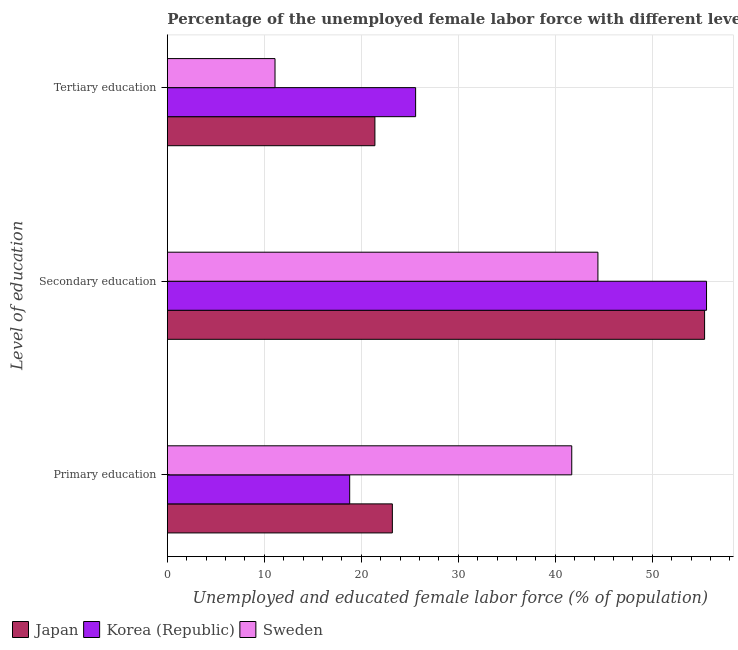How many groups of bars are there?
Keep it short and to the point. 3. How many bars are there on the 1st tick from the top?
Your answer should be very brief. 3. What is the label of the 2nd group of bars from the top?
Your answer should be compact. Secondary education. What is the percentage of female labor force who received tertiary education in Sweden?
Your answer should be compact. 11.1. Across all countries, what is the maximum percentage of female labor force who received tertiary education?
Keep it short and to the point. 25.6. Across all countries, what is the minimum percentage of female labor force who received primary education?
Keep it short and to the point. 18.8. In which country was the percentage of female labor force who received tertiary education minimum?
Keep it short and to the point. Sweden. What is the total percentage of female labor force who received secondary education in the graph?
Provide a short and direct response. 155.4. What is the difference between the percentage of female labor force who received secondary education in Korea (Republic) and that in Japan?
Offer a terse response. 0.2. What is the difference between the percentage of female labor force who received primary education in Sweden and the percentage of female labor force who received tertiary education in Japan?
Give a very brief answer. 20.3. What is the average percentage of female labor force who received secondary education per country?
Provide a short and direct response. 51.8. What is the difference between the percentage of female labor force who received tertiary education and percentage of female labor force who received primary education in Sweden?
Make the answer very short. -30.6. In how many countries, is the percentage of female labor force who received tertiary education greater than 46 %?
Provide a short and direct response. 0. What is the ratio of the percentage of female labor force who received tertiary education in Japan to that in Sweden?
Provide a short and direct response. 1.93. Is the difference between the percentage of female labor force who received primary education in Sweden and Korea (Republic) greater than the difference between the percentage of female labor force who received tertiary education in Sweden and Korea (Republic)?
Your answer should be very brief. Yes. What is the difference between the highest and the second highest percentage of female labor force who received secondary education?
Your answer should be compact. 0.2. What is the difference between the highest and the lowest percentage of female labor force who received primary education?
Give a very brief answer. 22.9. In how many countries, is the percentage of female labor force who received primary education greater than the average percentage of female labor force who received primary education taken over all countries?
Your answer should be very brief. 1. What does the 2nd bar from the bottom in Secondary education represents?
Keep it short and to the point. Korea (Republic). Is it the case that in every country, the sum of the percentage of female labor force who received primary education and percentage of female labor force who received secondary education is greater than the percentage of female labor force who received tertiary education?
Offer a very short reply. Yes. How many countries are there in the graph?
Give a very brief answer. 3. What is the difference between two consecutive major ticks on the X-axis?
Provide a short and direct response. 10. Does the graph contain grids?
Offer a very short reply. Yes. How many legend labels are there?
Ensure brevity in your answer.  3. How are the legend labels stacked?
Offer a very short reply. Horizontal. What is the title of the graph?
Keep it short and to the point. Percentage of the unemployed female labor force with different levels of education in countries. Does "Grenada" appear as one of the legend labels in the graph?
Provide a short and direct response. No. What is the label or title of the X-axis?
Your answer should be very brief. Unemployed and educated female labor force (% of population). What is the label or title of the Y-axis?
Give a very brief answer. Level of education. What is the Unemployed and educated female labor force (% of population) of Japan in Primary education?
Provide a short and direct response. 23.2. What is the Unemployed and educated female labor force (% of population) of Korea (Republic) in Primary education?
Your answer should be compact. 18.8. What is the Unemployed and educated female labor force (% of population) of Sweden in Primary education?
Your answer should be compact. 41.7. What is the Unemployed and educated female labor force (% of population) of Japan in Secondary education?
Ensure brevity in your answer.  55.4. What is the Unemployed and educated female labor force (% of population) in Korea (Republic) in Secondary education?
Offer a terse response. 55.6. What is the Unemployed and educated female labor force (% of population) in Sweden in Secondary education?
Your answer should be compact. 44.4. What is the Unemployed and educated female labor force (% of population) of Japan in Tertiary education?
Your answer should be very brief. 21.4. What is the Unemployed and educated female labor force (% of population) in Korea (Republic) in Tertiary education?
Give a very brief answer. 25.6. What is the Unemployed and educated female labor force (% of population) in Sweden in Tertiary education?
Ensure brevity in your answer.  11.1. Across all Level of education, what is the maximum Unemployed and educated female labor force (% of population) in Japan?
Keep it short and to the point. 55.4. Across all Level of education, what is the maximum Unemployed and educated female labor force (% of population) of Korea (Republic)?
Give a very brief answer. 55.6. Across all Level of education, what is the maximum Unemployed and educated female labor force (% of population) of Sweden?
Make the answer very short. 44.4. Across all Level of education, what is the minimum Unemployed and educated female labor force (% of population) in Japan?
Offer a very short reply. 21.4. Across all Level of education, what is the minimum Unemployed and educated female labor force (% of population) of Korea (Republic)?
Your response must be concise. 18.8. Across all Level of education, what is the minimum Unemployed and educated female labor force (% of population) in Sweden?
Offer a very short reply. 11.1. What is the total Unemployed and educated female labor force (% of population) of Sweden in the graph?
Make the answer very short. 97.2. What is the difference between the Unemployed and educated female labor force (% of population) in Japan in Primary education and that in Secondary education?
Provide a succinct answer. -32.2. What is the difference between the Unemployed and educated female labor force (% of population) in Korea (Republic) in Primary education and that in Secondary education?
Give a very brief answer. -36.8. What is the difference between the Unemployed and educated female labor force (% of population) of Japan in Primary education and that in Tertiary education?
Make the answer very short. 1.8. What is the difference between the Unemployed and educated female labor force (% of population) in Korea (Republic) in Primary education and that in Tertiary education?
Keep it short and to the point. -6.8. What is the difference between the Unemployed and educated female labor force (% of population) of Sweden in Primary education and that in Tertiary education?
Your answer should be compact. 30.6. What is the difference between the Unemployed and educated female labor force (% of population) of Japan in Secondary education and that in Tertiary education?
Offer a terse response. 34. What is the difference between the Unemployed and educated female labor force (% of population) of Sweden in Secondary education and that in Tertiary education?
Offer a terse response. 33.3. What is the difference between the Unemployed and educated female labor force (% of population) in Japan in Primary education and the Unemployed and educated female labor force (% of population) in Korea (Republic) in Secondary education?
Your response must be concise. -32.4. What is the difference between the Unemployed and educated female labor force (% of population) of Japan in Primary education and the Unemployed and educated female labor force (% of population) of Sweden in Secondary education?
Your answer should be compact. -21.2. What is the difference between the Unemployed and educated female labor force (% of population) in Korea (Republic) in Primary education and the Unemployed and educated female labor force (% of population) in Sweden in Secondary education?
Your response must be concise. -25.6. What is the difference between the Unemployed and educated female labor force (% of population) of Japan in Secondary education and the Unemployed and educated female labor force (% of population) of Korea (Republic) in Tertiary education?
Make the answer very short. 29.8. What is the difference between the Unemployed and educated female labor force (% of population) in Japan in Secondary education and the Unemployed and educated female labor force (% of population) in Sweden in Tertiary education?
Your answer should be very brief. 44.3. What is the difference between the Unemployed and educated female labor force (% of population) of Korea (Republic) in Secondary education and the Unemployed and educated female labor force (% of population) of Sweden in Tertiary education?
Provide a short and direct response. 44.5. What is the average Unemployed and educated female labor force (% of population) in Japan per Level of education?
Your response must be concise. 33.33. What is the average Unemployed and educated female labor force (% of population) in Korea (Republic) per Level of education?
Your answer should be compact. 33.33. What is the average Unemployed and educated female labor force (% of population) of Sweden per Level of education?
Make the answer very short. 32.4. What is the difference between the Unemployed and educated female labor force (% of population) of Japan and Unemployed and educated female labor force (% of population) of Korea (Republic) in Primary education?
Keep it short and to the point. 4.4. What is the difference between the Unemployed and educated female labor force (% of population) in Japan and Unemployed and educated female labor force (% of population) in Sweden in Primary education?
Give a very brief answer. -18.5. What is the difference between the Unemployed and educated female labor force (% of population) of Korea (Republic) and Unemployed and educated female labor force (% of population) of Sweden in Primary education?
Your response must be concise. -22.9. What is the difference between the Unemployed and educated female labor force (% of population) of Korea (Republic) and Unemployed and educated female labor force (% of population) of Sweden in Secondary education?
Provide a short and direct response. 11.2. What is the difference between the Unemployed and educated female labor force (% of population) in Japan and Unemployed and educated female labor force (% of population) in Sweden in Tertiary education?
Provide a short and direct response. 10.3. What is the difference between the Unemployed and educated female labor force (% of population) of Korea (Republic) and Unemployed and educated female labor force (% of population) of Sweden in Tertiary education?
Give a very brief answer. 14.5. What is the ratio of the Unemployed and educated female labor force (% of population) of Japan in Primary education to that in Secondary education?
Make the answer very short. 0.42. What is the ratio of the Unemployed and educated female labor force (% of population) in Korea (Republic) in Primary education to that in Secondary education?
Your answer should be very brief. 0.34. What is the ratio of the Unemployed and educated female labor force (% of population) in Sweden in Primary education to that in Secondary education?
Ensure brevity in your answer.  0.94. What is the ratio of the Unemployed and educated female labor force (% of population) of Japan in Primary education to that in Tertiary education?
Give a very brief answer. 1.08. What is the ratio of the Unemployed and educated female labor force (% of population) of Korea (Republic) in Primary education to that in Tertiary education?
Ensure brevity in your answer.  0.73. What is the ratio of the Unemployed and educated female labor force (% of population) of Sweden in Primary education to that in Tertiary education?
Offer a very short reply. 3.76. What is the ratio of the Unemployed and educated female labor force (% of population) in Japan in Secondary education to that in Tertiary education?
Offer a very short reply. 2.59. What is the ratio of the Unemployed and educated female labor force (% of population) of Korea (Republic) in Secondary education to that in Tertiary education?
Offer a terse response. 2.17. What is the ratio of the Unemployed and educated female labor force (% of population) of Sweden in Secondary education to that in Tertiary education?
Provide a succinct answer. 4. What is the difference between the highest and the second highest Unemployed and educated female labor force (% of population) of Japan?
Your answer should be very brief. 32.2. What is the difference between the highest and the second highest Unemployed and educated female labor force (% of population) in Sweden?
Provide a succinct answer. 2.7. What is the difference between the highest and the lowest Unemployed and educated female labor force (% of population) of Korea (Republic)?
Offer a terse response. 36.8. What is the difference between the highest and the lowest Unemployed and educated female labor force (% of population) of Sweden?
Provide a short and direct response. 33.3. 